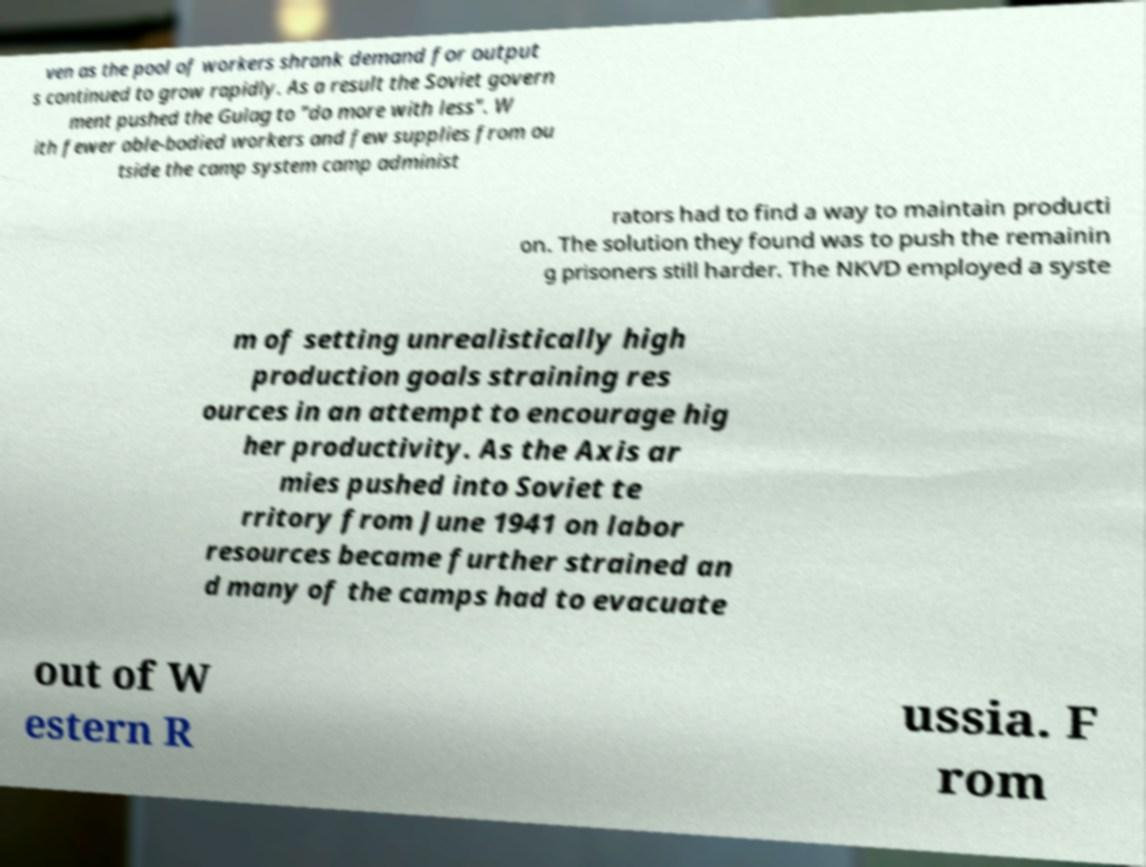Could you assist in decoding the text presented in this image and type it out clearly? ven as the pool of workers shrank demand for output s continued to grow rapidly. As a result the Soviet govern ment pushed the Gulag to "do more with less". W ith fewer able-bodied workers and few supplies from ou tside the camp system camp administ rators had to find a way to maintain producti on. The solution they found was to push the remainin g prisoners still harder. The NKVD employed a syste m of setting unrealistically high production goals straining res ources in an attempt to encourage hig her productivity. As the Axis ar mies pushed into Soviet te rritory from June 1941 on labor resources became further strained an d many of the camps had to evacuate out of W estern R ussia. F rom 